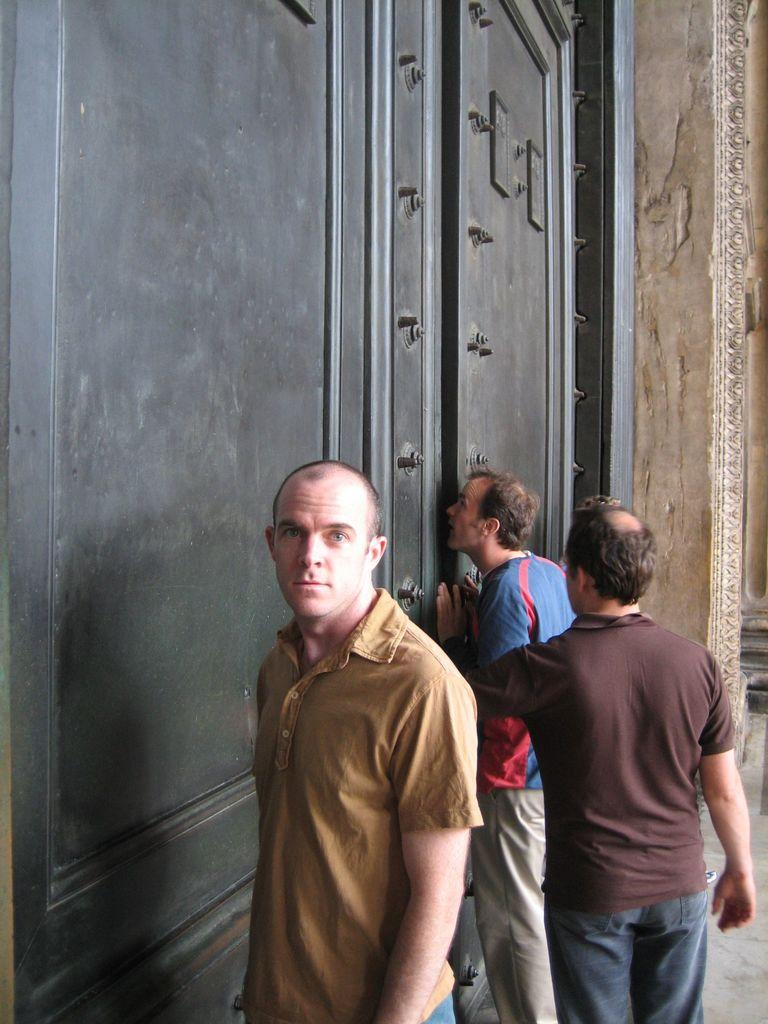How many people are in the foreground of the picture? There are three people in the foreground of the picture. What is located in the foreground of the picture alongside the people? There is a door in the foreground of the picture. Can you describe any architectural features visible in the image? Yes, there is a wall visible at the top right of the image. What type of hair can be seen on the bushes in the image? There are no bushes or hair present in the image. 